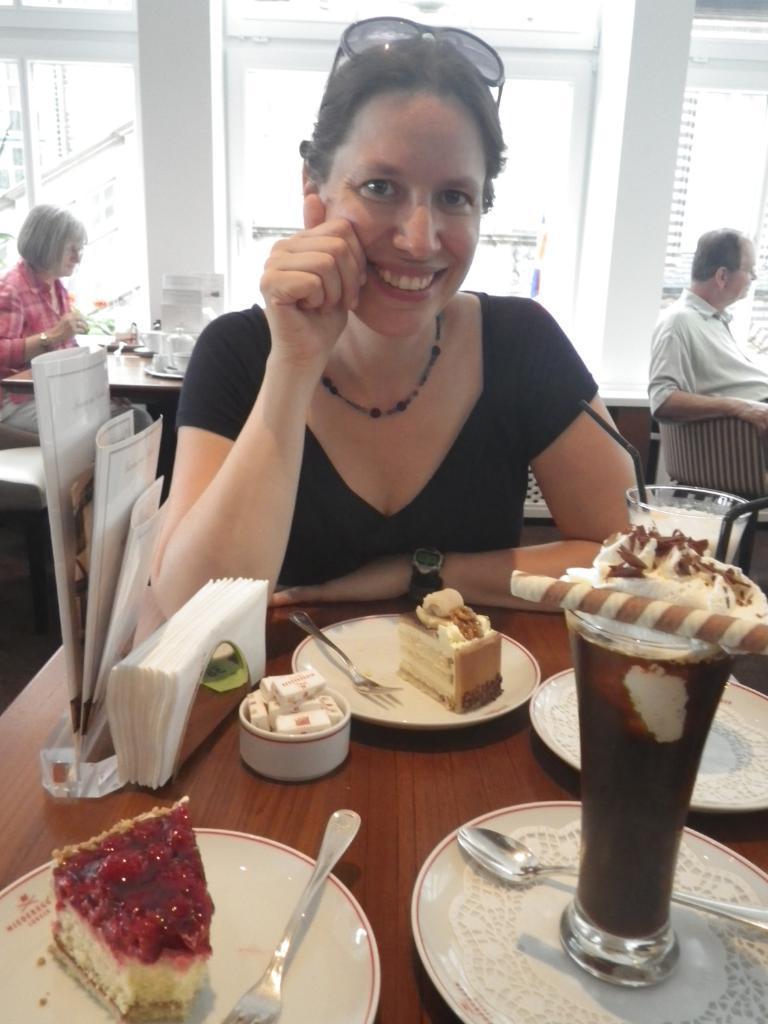Could you give a brief overview of what you see in this image? In the image we can see there is a woman sitting, wearing clothes, wrist watch, neck chain and in front of her there is a table. On the table there are plates, in the plate there are food items, this is a bowl, glass, spoon, tissue papers and a straw. Behind her there are other people sitting, this is a window and goggles. 